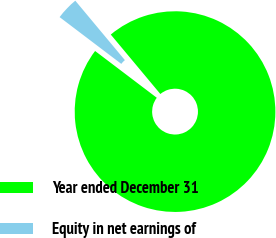<chart> <loc_0><loc_0><loc_500><loc_500><pie_chart><fcel>Year ended December 31<fcel>Equity in net earnings of<nl><fcel>96.39%<fcel>3.61%<nl></chart> 